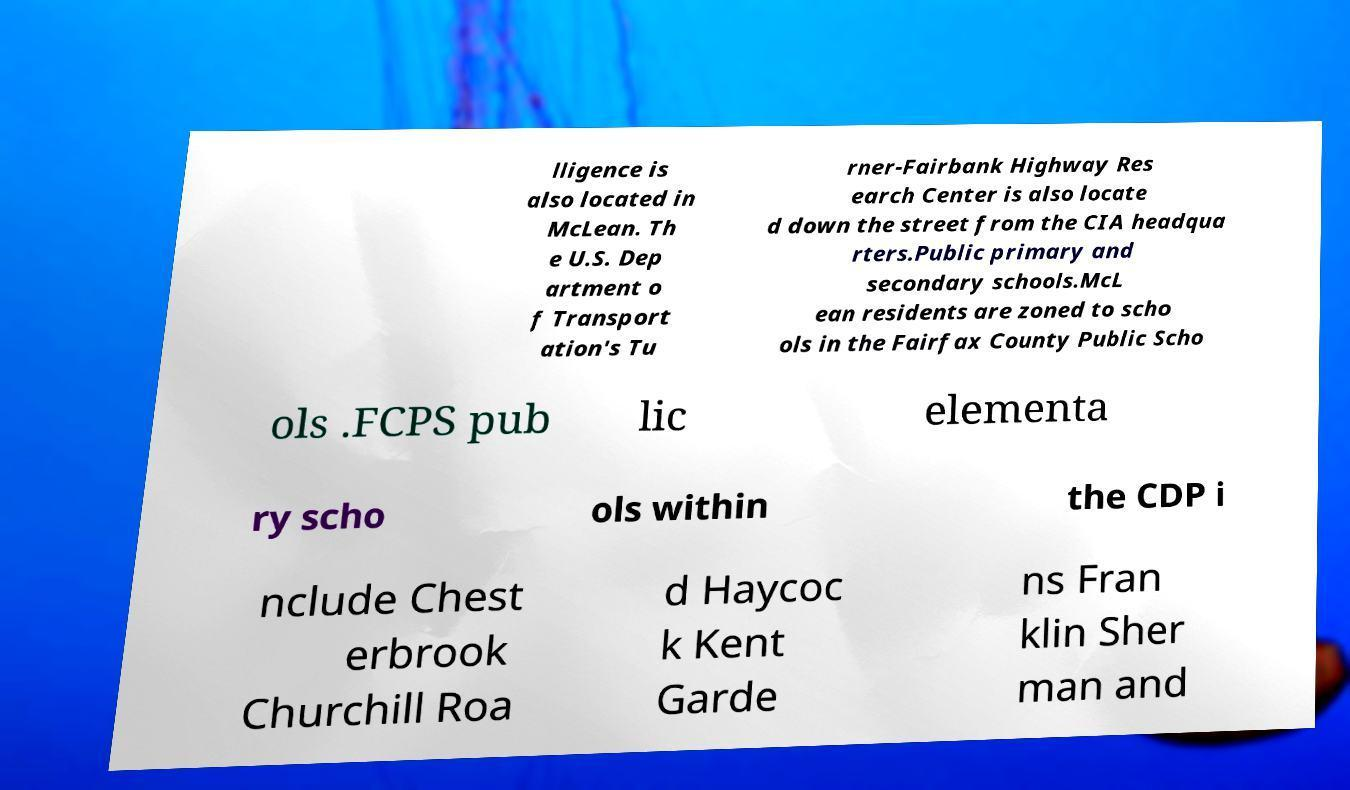For documentation purposes, I need the text within this image transcribed. Could you provide that? lligence is also located in McLean. Th e U.S. Dep artment o f Transport ation's Tu rner-Fairbank Highway Res earch Center is also locate d down the street from the CIA headqua rters.Public primary and secondary schools.McL ean residents are zoned to scho ols in the Fairfax County Public Scho ols .FCPS pub lic elementa ry scho ols within the CDP i nclude Chest erbrook Churchill Roa d Haycoc k Kent Garde ns Fran klin Sher man and 